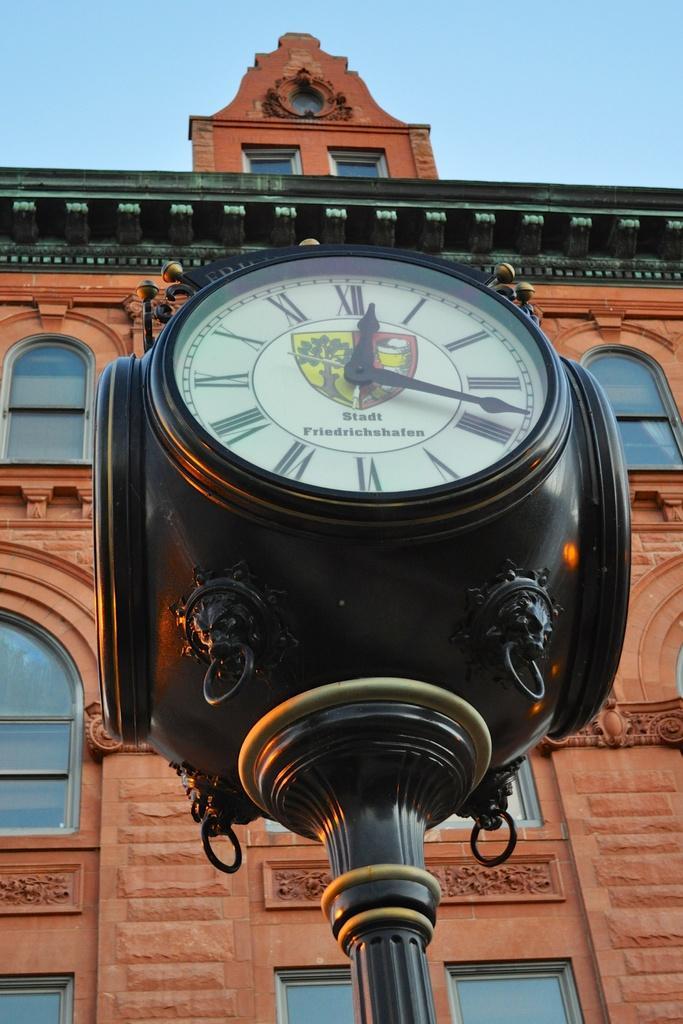In one or two sentences, can you explain what this image depicts? In this image we can see there is a wall clock, behind that there is a building. In the background there is a sky. 